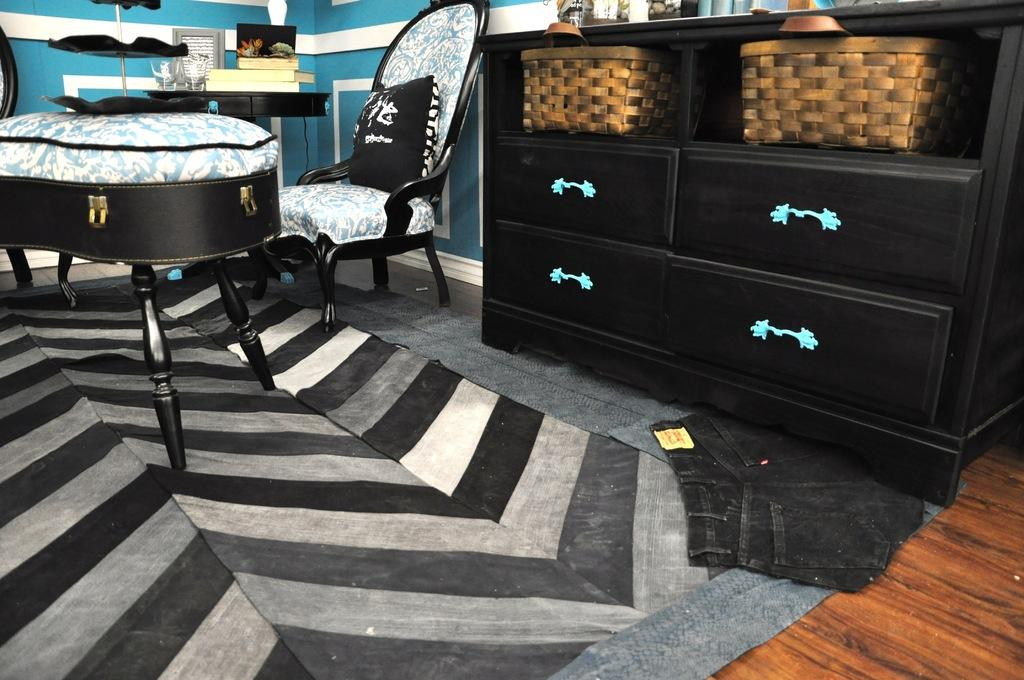What type of furniture is present in the image? There is a table, a chair, and a cupboard desk in the image. What is on the floor in the room? There is a carpet on the floor in the room. What can be seen in the background of the image? There is a wall in the background of the image. What items are on the table in the image? There are books on the table in the image. What type of dinner is being served on the table in the image? There is no dinner present in the image; only books are on the table. What type of building is depicted in the image? The image does not depict a building; it shows a room with furniture and books. 